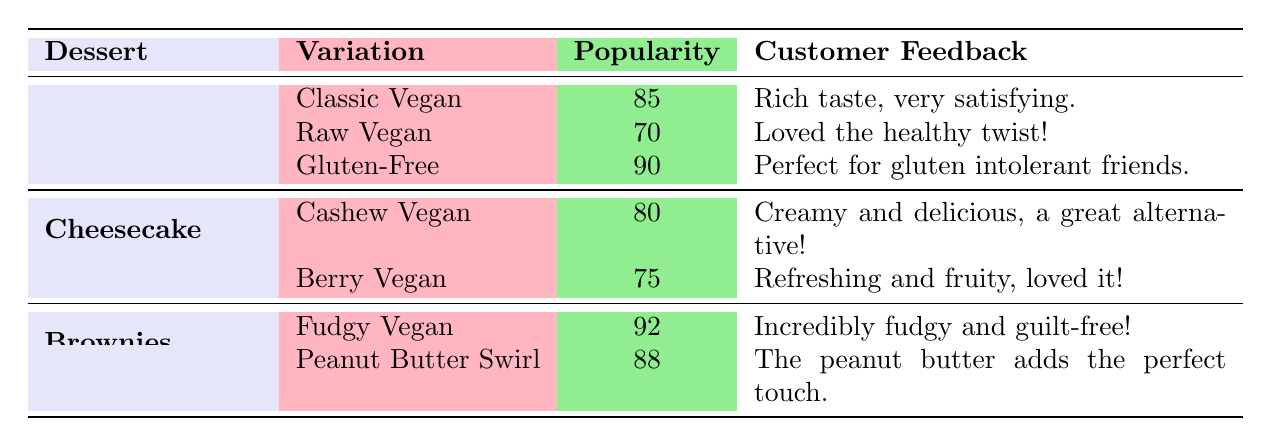What is the popularity score of the Classic Vegan Chocolate Cake? The table directly lists the popularity score for the Classic Vegan Chocolate Cake as 85.
Answer: 85 Which cheesecake variation has a higher popularity score, Cashew Vegan or Berry Vegan? The popularity score for Cashew Vegan Cheesecake is 80, while Berry Vegan Cheesecake has a score of 75. Hence, Cashew Vegan has the higher score.
Answer: Cashew Vegan What are the ingredients for the Fudgy Vegan Brownies? The table lists the ingredients for Fudgy Vegan Brownies as black beans, cocoa powder, banana, and maple syrup.
Answer: Black beans, cocoa powder, banana, maple syrup What is the average popularity score of all Chocolate Cake variations? The popularity scores for the Chocolate Cake variations are 85, 70, and 90. The average is calculated as (85 + 70 + 90) / 3 = 81.67.
Answer: 81.67 Is there any dessert with a popularity score of 95 or higher? Looking at the table, the highest popularity score is 92 for Fudgy Vegan Brownies, which is less than 95. Therefore, the answer is no.
Answer: No Which dessert has the widest range of popularity scores among its variations? The dessert with the widest range is Brownies, with scores of 92 and 88, giving a range of 4. Chocolate Cake has a range of 20 (90 - 70), while Cheesecake has a range of 5 (80 - 75).
Answer: Chocolate Cake How many variations of Cheesecake are listed in the table? The table shows two variations for Cheesecake: Cashew Vegan and Berry Vegan. Thus, the total count is 2.
Answer: 2 Which dessert variation received the most positive customer feedback? The Fudgy Vegan Brownies received feedback describing them as "Incredibly fudgy and guilt-free!" which is quite positive compared to others.
Answer: Fudgy Vegan Brownies 